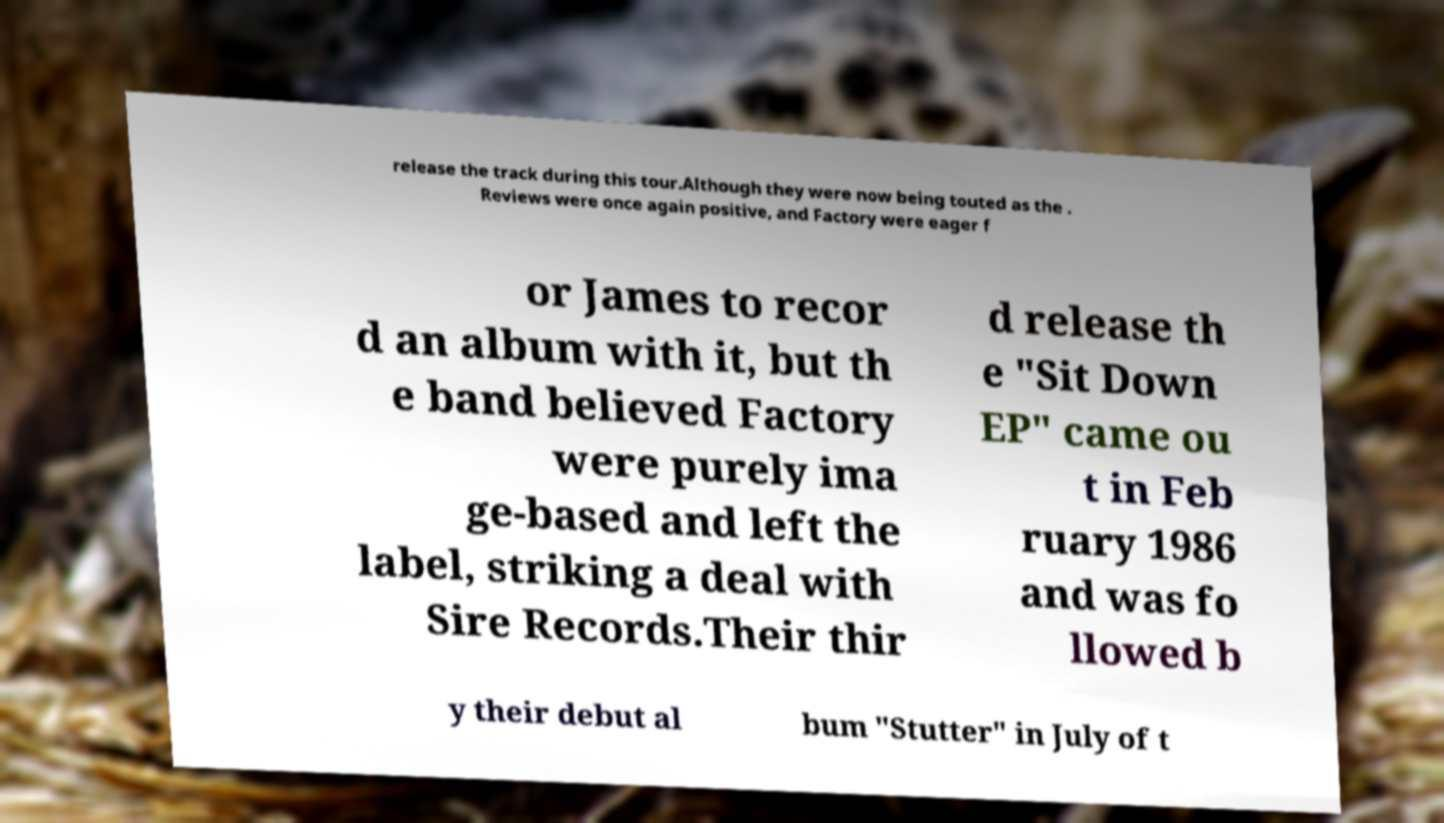I need the written content from this picture converted into text. Can you do that? release the track during this tour.Although they were now being touted as the . Reviews were once again positive, and Factory were eager f or James to recor d an album with it, but th e band believed Factory were purely ima ge-based and left the label, striking a deal with Sire Records.Their thir d release th e "Sit Down EP" came ou t in Feb ruary 1986 and was fo llowed b y their debut al bum "Stutter" in July of t 